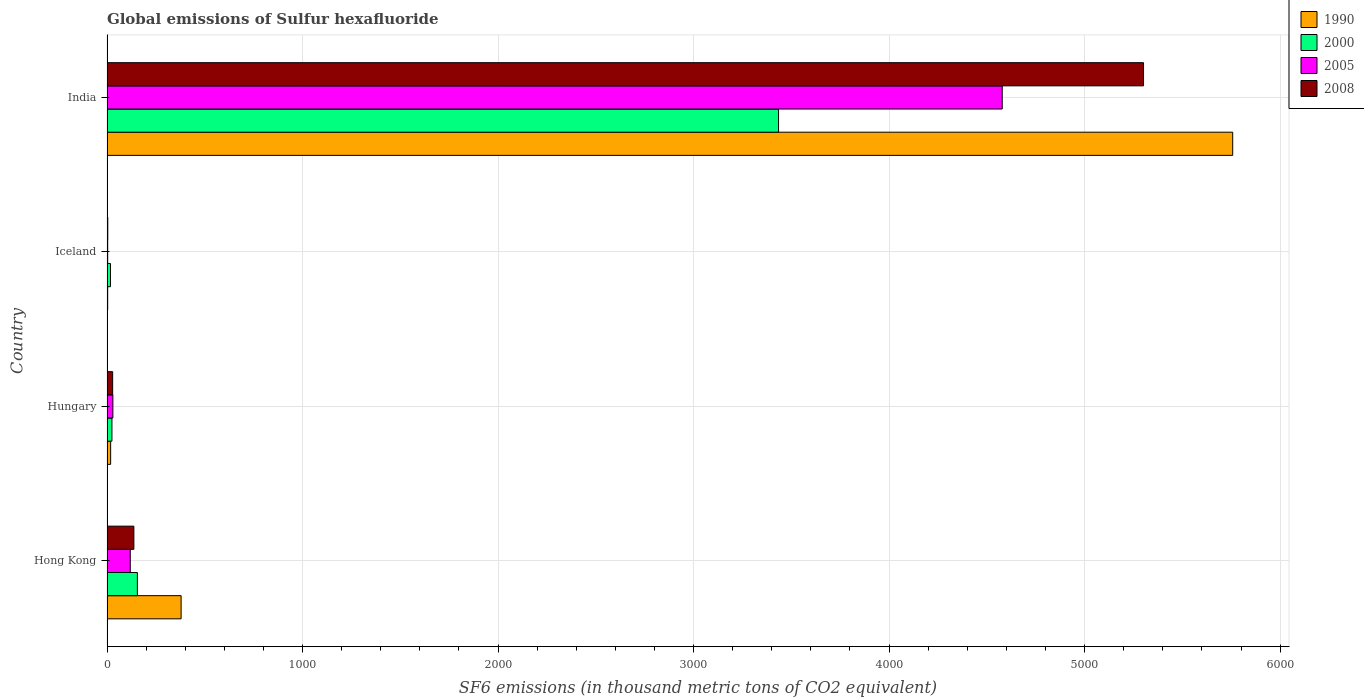How many groups of bars are there?
Provide a short and direct response. 4. Are the number of bars on each tick of the Y-axis equal?
Give a very brief answer. Yes. How many bars are there on the 4th tick from the bottom?
Offer a very short reply. 4. What is the global emissions of Sulfur hexafluoride in 1990 in India?
Keep it short and to the point. 5757.5. Across all countries, what is the maximum global emissions of Sulfur hexafluoride in 2008?
Your answer should be compact. 5301.4. In which country was the global emissions of Sulfur hexafluoride in 2000 maximum?
Keep it short and to the point. India. In which country was the global emissions of Sulfur hexafluoride in 2005 minimum?
Provide a short and direct response. Iceland. What is the total global emissions of Sulfur hexafluoride in 2000 in the graph?
Provide a short and direct response. 3633.1. What is the difference between the global emissions of Sulfur hexafluoride in 1990 in Hungary and that in Iceland?
Make the answer very short. 15.1. What is the difference between the global emissions of Sulfur hexafluoride in 2008 in India and the global emissions of Sulfur hexafluoride in 1990 in Iceland?
Give a very brief answer. 5297.9. What is the average global emissions of Sulfur hexafluoride in 1990 per country?
Ensure brevity in your answer.  1539.65. What is the difference between the global emissions of Sulfur hexafluoride in 2000 and global emissions of Sulfur hexafluoride in 2005 in Iceland?
Offer a very short reply. 14.4. Is the global emissions of Sulfur hexafluoride in 2005 in Hungary less than that in India?
Provide a short and direct response. Yes. Is the difference between the global emissions of Sulfur hexafluoride in 2000 in Hong Kong and India greater than the difference between the global emissions of Sulfur hexafluoride in 2005 in Hong Kong and India?
Offer a very short reply. Yes. What is the difference between the highest and the second highest global emissions of Sulfur hexafluoride in 2008?
Keep it short and to the point. 5164. What is the difference between the highest and the lowest global emissions of Sulfur hexafluoride in 2005?
Make the answer very short. 4575.2. How many countries are there in the graph?
Keep it short and to the point. 4. Does the graph contain grids?
Offer a very short reply. Yes. Where does the legend appear in the graph?
Offer a very short reply. Top right. How many legend labels are there?
Offer a terse response. 4. How are the legend labels stacked?
Keep it short and to the point. Vertical. What is the title of the graph?
Your answer should be compact. Global emissions of Sulfur hexafluoride. What is the label or title of the X-axis?
Keep it short and to the point. SF6 emissions (in thousand metric tons of CO2 equivalent). What is the SF6 emissions (in thousand metric tons of CO2 equivalent) of 1990 in Hong Kong?
Keep it short and to the point. 379. What is the SF6 emissions (in thousand metric tons of CO2 equivalent) in 2000 in Hong Kong?
Your answer should be very brief. 155.3. What is the SF6 emissions (in thousand metric tons of CO2 equivalent) in 2005 in Hong Kong?
Offer a very short reply. 119. What is the SF6 emissions (in thousand metric tons of CO2 equivalent) in 2008 in Hong Kong?
Offer a terse response. 137.4. What is the SF6 emissions (in thousand metric tons of CO2 equivalent) in 1990 in Hungary?
Your response must be concise. 18.6. What is the SF6 emissions (in thousand metric tons of CO2 equivalent) in 2000 in Hungary?
Give a very brief answer. 25.2. What is the SF6 emissions (in thousand metric tons of CO2 equivalent) of 2008 in Hungary?
Provide a short and direct response. 28.9. What is the SF6 emissions (in thousand metric tons of CO2 equivalent) in 1990 in Iceland?
Make the answer very short. 3.5. What is the SF6 emissions (in thousand metric tons of CO2 equivalent) of 2000 in Iceland?
Provide a short and direct response. 17.9. What is the SF6 emissions (in thousand metric tons of CO2 equivalent) in 2005 in Iceland?
Provide a short and direct response. 3.5. What is the SF6 emissions (in thousand metric tons of CO2 equivalent) in 1990 in India?
Provide a succinct answer. 5757.5. What is the SF6 emissions (in thousand metric tons of CO2 equivalent) in 2000 in India?
Provide a short and direct response. 3434.7. What is the SF6 emissions (in thousand metric tons of CO2 equivalent) in 2005 in India?
Your response must be concise. 4578.7. What is the SF6 emissions (in thousand metric tons of CO2 equivalent) in 2008 in India?
Your response must be concise. 5301.4. Across all countries, what is the maximum SF6 emissions (in thousand metric tons of CO2 equivalent) of 1990?
Provide a succinct answer. 5757.5. Across all countries, what is the maximum SF6 emissions (in thousand metric tons of CO2 equivalent) of 2000?
Make the answer very short. 3434.7. Across all countries, what is the maximum SF6 emissions (in thousand metric tons of CO2 equivalent) in 2005?
Your response must be concise. 4578.7. Across all countries, what is the maximum SF6 emissions (in thousand metric tons of CO2 equivalent) in 2008?
Provide a short and direct response. 5301.4. Across all countries, what is the minimum SF6 emissions (in thousand metric tons of CO2 equivalent) in 1990?
Keep it short and to the point. 3.5. Across all countries, what is the minimum SF6 emissions (in thousand metric tons of CO2 equivalent) of 2000?
Your answer should be very brief. 17.9. Across all countries, what is the minimum SF6 emissions (in thousand metric tons of CO2 equivalent) in 2005?
Provide a succinct answer. 3.5. What is the total SF6 emissions (in thousand metric tons of CO2 equivalent) of 1990 in the graph?
Give a very brief answer. 6158.6. What is the total SF6 emissions (in thousand metric tons of CO2 equivalent) in 2000 in the graph?
Offer a very short reply. 3633.1. What is the total SF6 emissions (in thousand metric tons of CO2 equivalent) of 2005 in the graph?
Your response must be concise. 4731.2. What is the total SF6 emissions (in thousand metric tons of CO2 equivalent) of 2008 in the graph?
Keep it short and to the point. 5471.7. What is the difference between the SF6 emissions (in thousand metric tons of CO2 equivalent) in 1990 in Hong Kong and that in Hungary?
Keep it short and to the point. 360.4. What is the difference between the SF6 emissions (in thousand metric tons of CO2 equivalent) of 2000 in Hong Kong and that in Hungary?
Provide a short and direct response. 130.1. What is the difference between the SF6 emissions (in thousand metric tons of CO2 equivalent) of 2005 in Hong Kong and that in Hungary?
Provide a short and direct response. 89. What is the difference between the SF6 emissions (in thousand metric tons of CO2 equivalent) in 2008 in Hong Kong and that in Hungary?
Ensure brevity in your answer.  108.5. What is the difference between the SF6 emissions (in thousand metric tons of CO2 equivalent) of 1990 in Hong Kong and that in Iceland?
Make the answer very short. 375.5. What is the difference between the SF6 emissions (in thousand metric tons of CO2 equivalent) in 2000 in Hong Kong and that in Iceland?
Your response must be concise. 137.4. What is the difference between the SF6 emissions (in thousand metric tons of CO2 equivalent) of 2005 in Hong Kong and that in Iceland?
Offer a very short reply. 115.5. What is the difference between the SF6 emissions (in thousand metric tons of CO2 equivalent) of 2008 in Hong Kong and that in Iceland?
Your answer should be very brief. 133.4. What is the difference between the SF6 emissions (in thousand metric tons of CO2 equivalent) in 1990 in Hong Kong and that in India?
Offer a very short reply. -5378.5. What is the difference between the SF6 emissions (in thousand metric tons of CO2 equivalent) in 2000 in Hong Kong and that in India?
Your answer should be compact. -3279.4. What is the difference between the SF6 emissions (in thousand metric tons of CO2 equivalent) of 2005 in Hong Kong and that in India?
Give a very brief answer. -4459.7. What is the difference between the SF6 emissions (in thousand metric tons of CO2 equivalent) in 2008 in Hong Kong and that in India?
Your answer should be very brief. -5164. What is the difference between the SF6 emissions (in thousand metric tons of CO2 equivalent) of 1990 in Hungary and that in Iceland?
Offer a terse response. 15.1. What is the difference between the SF6 emissions (in thousand metric tons of CO2 equivalent) in 2000 in Hungary and that in Iceland?
Give a very brief answer. 7.3. What is the difference between the SF6 emissions (in thousand metric tons of CO2 equivalent) of 2005 in Hungary and that in Iceland?
Offer a terse response. 26.5. What is the difference between the SF6 emissions (in thousand metric tons of CO2 equivalent) in 2008 in Hungary and that in Iceland?
Make the answer very short. 24.9. What is the difference between the SF6 emissions (in thousand metric tons of CO2 equivalent) of 1990 in Hungary and that in India?
Offer a terse response. -5738.9. What is the difference between the SF6 emissions (in thousand metric tons of CO2 equivalent) in 2000 in Hungary and that in India?
Offer a terse response. -3409.5. What is the difference between the SF6 emissions (in thousand metric tons of CO2 equivalent) of 2005 in Hungary and that in India?
Your answer should be very brief. -4548.7. What is the difference between the SF6 emissions (in thousand metric tons of CO2 equivalent) of 2008 in Hungary and that in India?
Ensure brevity in your answer.  -5272.5. What is the difference between the SF6 emissions (in thousand metric tons of CO2 equivalent) of 1990 in Iceland and that in India?
Your answer should be compact. -5754. What is the difference between the SF6 emissions (in thousand metric tons of CO2 equivalent) in 2000 in Iceland and that in India?
Provide a short and direct response. -3416.8. What is the difference between the SF6 emissions (in thousand metric tons of CO2 equivalent) of 2005 in Iceland and that in India?
Keep it short and to the point. -4575.2. What is the difference between the SF6 emissions (in thousand metric tons of CO2 equivalent) in 2008 in Iceland and that in India?
Keep it short and to the point. -5297.4. What is the difference between the SF6 emissions (in thousand metric tons of CO2 equivalent) of 1990 in Hong Kong and the SF6 emissions (in thousand metric tons of CO2 equivalent) of 2000 in Hungary?
Provide a succinct answer. 353.8. What is the difference between the SF6 emissions (in thousand metric tons of CO2 equivalent) in 1990 in Hong Kong and the SF6 emissions (in thousand metric tons of CO2 equivalent) in 2005 in Hungary?
Provide a short and direct response. 349. What is the difference between the SF6 emissions (in thousand metric tons of CO2 equivalent) in 1990 in Hong Kong and the SF6 emissions (in thousand metric tons of CO2 equivalent) in 2008 in Hungary?
Provide a succinct answer. 350.1. What is the difference between the SF6 emissions (in thousand metric tons of CO2 equivalent) of 2000 in Hong Kong and the SF6 emissions (in thousand metric tons of CO2 equivalent) of 2005 in Hungary?
Provide a succinct answer. 125.3. What is the difference between the SF6 emissions (in thousand metric tons of CO2 equivalent) in 2000 in Hong Kong and the SF6 emissions (in thousand metric tons of CO2 equivalent) in 2008 in Hungary?
Provide a succinct answer. 126.4. What is the difference between the SF6 emissions (in thousand metric tons of CO2 equivalent) in 2005 in Hong Kong and the SF6 emissions (in thousand metric tons of CO2 equivalent) in 2008 in Hungary?
Your answer should be very brief. 90.1. What is the difference between the SF6 emissions (in thousand metric tons of CO2 equivalent) in 1990 in Hong Kong and the SF6 emissions (in thousand metric tons of CO2 equivalent) in 2000 in Iceland?
Provide a short and direct response. 361.1. What is the difference between the SF6 emissions (in thousand metric tons of CO2 equivalent) in 1990 in Hong Kong and the SF6 emissions (in thousand metric tons of CO2 equivalent) in 2005 in Iceland?
Offer a terse response. 375.5. What is the difference between the SF6 emissions (in thousand metric tons of CO2 equivalent) of 1990 in Hong Kong and the SF6 emissions (in thousand metric tons of CO2 equivalent) of 2008 in Iceland?
Keep it short and to the point. 375. What is the difference between the SF6 emissions (in thousand metric tons of CO2 equivalent) in 2000 in Hong Kong and the SF6 emissions (in thousand metric tons of CO2 equivalent) in 2005 in Iceland?
Offer a very short reply. 151.8. What is the difference between the SF6 emissions (in thousand metric tons of CO2 equivalent) in 2000 in Hong Kong and the SF6 emissions (in thousand metric tons of CO2 equivalent) in 2008 in Iceland?
Your answer should be compact. 151.3. What is the difference between the SF6 emissions (in thousand metric tons of CO2 equivalent) in 2005 in Hong Kong and the SF6 emissions (in thousand metric tons of CO2 equivalent) in 2008 in Iceland?
Keep it short and to the point. 115. What is the difference between the SF6 emissions (in thousand metric tons of CO2 equivalent) in 1990 in Hong Kong and the SF6 emissions (in thousand metric tons of CO2 equivalent) in 2000 in India?
Ensure brevity in your answer.  -3055.7. What is the difference between the SF6 emissions (in thousand metric tons of CO2 equivalent) in 1990 in Hong Kong and the SF6 emissions (in thousand metric tons of CO2 equivalent) in 2005 in India?
Provide a succinct answer. -4199.7. What is the difference between the SF6 emissions (in thousand metric tons of CO2 equivalent) in 1990 in Hong Kong and the SF6 emissions (in thousand metric tons of CO2 equivalent) in 2008 in India?
Your response must be concise. -4922.4. What is the difference between the SF6 emissions (in thousand metric tons of CO2 equivalent) in 2000 in Hong Kong and the SF6 emissions (in thousand metric tons of CO2 equivalent) in 2005 in India?
Keep it short and to the point. -4423.4. What is the difference between the SF6 emissions (in thousand metric tons of CO2 equivalent) of 2000 in Hong Kong and the SF6 emissions (in thousand metric tons of CO2 equivalent) of 2008 in India?
Provide a succinct answer. -5146.1. What is the difference between the SF6 emissions (in thousand metric tons of CO2 equivalent) of 2005 in Hong Kong and the SF6 emissions (in thousand metric tons of CO2 equivalent) of 2008 in India?
Make the answer very short. -5182.4. What is the difference between the SF6 emissions (in thousand metric tons of CO2 equivalent) in 1990 in Hungary and the SF6 emissions (in thousand metric tons of CO2 equivalent) in 2005 in Iceland?
Give a very brief answer. 15.1. What is the difference between the SF6 emissions (in thousand metric tons of CO2 equivalent) of 1990 in Hungary and the SF6 emissions (in thousand metric tons of CO2 equivalent) of 2008 in Iceland?
Offer a terse response. 14.6. What is the difference between the SF6 emissions (in thousand metric tons of CO2 equivalent) of 2000 in Hungary and the SF6 emissions (in thousand metric tons of CO2 equivalent) of 2005 in Iceland?
Provide a succinct answer. 21.7. What is the difference between the SF6 emissions (in thousand metric tons of CO2 equivalent) of 2000 in Hungary and the SF6 emissions (in thousand metric tons of CO2 equivalent) of 2008 in Iceland?
Your response must be concise. 21.2. What is the difference between the SF6 emissions (in thousand metric tons of CO2 equivalent) in 1990 in Hungary and the SF6 emissions (in thousand metric tons of CO2 equivalent) in 2000 in India?
Your response must be concise. -3416.1. What is the difference between the SF6 emissions (in thousand metric tons of CO2 equivalent) in 1990 in Hungary and the SF6 emissions (in thousand metric tons of CO2 equivalent) in 2005 in India?
Keep it short and to the point. -4560.1. What is the difference between the SF6 emissions (in thousand metric tons of CO2 equivalent) of 1990 in Hungary and the SF6 emissions (in thousand metric tons of CO2 equivalent) of 2008 in India?
Your answer should be very brief. -5282.8. What is the difference between the SF6 emissions (in thousand metric tons of CO2 equivalent) in 2000 in Hungary and the SF6 emissions (in thousand metric tons of CO2 equivalent) in 2005 in India?
Your response must be concise. -4553.5. What is the difference between the SF6 emissions (in thousand metric tons of CO2 equivalent) in 2000 in Hungary and the SF6 emissions (in thousand metric tons of CO2 equivalent) in 2008 in India?
Ensure brevity in your answer.  -5276.2. What is the difference between the SF6 emissions (in thousand metric tons of CO2 equivalent) in 2005 in Hungary and the SF6 emissions (in thousand metric tons of CO2 equivalent) in 2008 in India?
Make the answer very short. -5271.4. What is the difference between the SF6 emissions (in thousand metric tons of CO2 equivalent) of 1990 in Iceland and the SF6 emissions (in thousand metric tons of CO2 equivalent) of 2000 in India?
Make the answer very short. -3431.2. What is the difference between the SF6 emissions (in thousand metric tons of CO2 equivalent) in 1990 in Iceland and the SF6 emissions (in thousand metric tons of CO2 equivalent) in 2005 in India?
Offer a terse response. -4575.2. What is the difference between the SF6 emissions (in thousand metric tons of CO2 equivalent) of 1990 in Iceland and the SF6 emissions (in thousand metric tons of CO2 equivalent) of 2008 in India?
Ensure brevity in your answer.  -5297.9. What is the difference between the SF6 emissions (in thousand metric tons of CO2 equivalent) in 2000 in Iceland and the SF6 emissions (in thousand metric tons of CO2 equivalent) in 2005 in India?
Provide a succinct answer. -4560.8. What is the difference between the SF6 emissions (in thousand metric tons of CO2 equivalent) in 2000 in Iceland and the SF6 emissions (in thousand metric tons of CO2 equivalent) in 2008 in India?
Provide a succinct answer. -5283.5. What is the difference between the SF6 emissions (in thousand metric tons of CO2 equivalent) of 2005 in Iceland and the SF6 emissions (in thousand metric tons of CO2 equivalent) of 2008 in India?
Offer a terse response. -5297.9. What is the average SF6 emissions (in thousand metric tons of CO2 equivalent) in 1990 per country?
Provide a succinct answer. 1539.65. What is the average SF6 emissions (in thousand metric tons of CO2 equivalent) of 2000 per country?
Provide a succinct answer. 908.27. What is the average SF6 emissions (in thousand metric tons of CO2 equivalent) in 2005 per country?
Keep it short and to the point. 1182.8. What is the average SF6 emissions (in thousand metric tons of CO2 equivalent) of 2008 per country?
Provide a short and direct response. 1367.92. What is the difference between the SF6 emissions (in thousand metric tons of CO2 equivalent) in 1990 and SF6 emissions (in thousand metric tons of CO2 equivalent) in 2000 in Hong Kong?
Your response must be concise. 223.7. What is the difference between the SF6 emissions (in thousand metric tons of CO2 equivalent) in 1990 and SF6 emissions (in thousand metric tons of CO2 equivalent) in 2005 in Hong Kong?
Offer a terse response. 260. What is the difference between the SF6 emissions (in thousand metric tons of CO2 equivalent) of 1990 and SF6 emissions (in thousand metric tons of CO2 equivalent) of 2008 in Hong Kong?
Your answer should be very brief. 241.6. What is the difference between the SF6 emissions (in thousand metric tons of CO2 equivalent) of 2000 and SF6 emissions (in thousand metric tons of CO2 equivalent) of 2005 in Hong Kong?
Your answer should be very brief. 36.3. What is the difference between the SF6 emissions (in thousand metric tons of CO2 equivalent) of 2005 and SF6 emissions (in thousand metric tons of CO2 equivalent) of 2008 in Hong Kong?
Provide a short and direct response. -18.4. What is the difference between the SF6 emissions (in thousand metric tons of CO2 equivalent) in 1990 and SF6 emissions (in thousand metric tons of CO2 equivalent) in 2005 in Hungary?
Your answer should be compact. -11.4. What is the difference between the SF6 emissions (in thousand metric tons of CO2 equivalent) in 2000 and SF6 emissions (in thousand metric tons of CO2 equivalent) in 2005 in Hungary?
Provide a succinct answer. -4.8. What is the difference between the SF6 emissions (in thousand metric tons of CO2 equivalent) in 2005 and SF6 emissions (in thousand metric tons of CO2 equivalent) in 2008 in Hungary?
Provide a short and direct response. 1.1. What is the difference between the SF6 emissions (in thousand metric tons of CO2 equivalent) of 1990 and SF6 emissions (in thousand metric tons of CO2 equivalent) of 2000 in Iceland?
Ensure brevity in your answer.  -14.4. What is the difference between the SF6 emissions (in thousand metric tons of CO2 equivalent) of 2005 and SF6 emissions (in thousand metric tons of CO2 equivalent) of 2008 in Iceland?
Make the answer very short. -0.5. What is the difference between the SF6 emissions (in thousand metric tons of CO2 equivalent) of 1990 and SF6 emissions (in thousand metric tons of CO2 equivalent) of 2000 in India?
Offer a very short reply. 2322.8. What is the difference between the SF6 emissions (in thousand metric tons of CO2 equivalent) in 1990 and SF6 emissions (in thousand metric tons of CO2 equivalent) in 2005 in India?
Provide a short and direct response. 1178.8. What is the difference between the SF6 emissions (in thousand metric tons of CO2 equivalent) in 1990 and SF6 emissions (in thousand metric tons of CO2 equivalent) in 2008 in India?
Provide a short and direct response. 456.1. What is the difference between the SF6 emissions (in thousand metric tons of CO2 equivalent) of 2000 and SF6 emissions (in thousand metric tons of CO2 equivalent) of 2005 in India?
Make the answer very short. -1144. What is the difference between the SF6 emissions (in thousand metric tons of CO2 equivalent) of 2000 and SF6 emissions (in thousand metric tons of CO2 equivalent) of 2008 in India?
Your response must be concise. -1866.7. What is the difference between the SF6 emissions (in thousand metric tons of CO2 equivalent) of 2005 and SF6 emissions (in thousand metric tons of CO2 equivalent) of 2008 in India?
Offer a terse response. -722.7. What is the ratio of the SF6 emissions (in thousand metric tons of CO2 equivalent) of 1990 in Hong Kong to that in Hungary?
Offer a very short reply. 20.38. What is the ratio of the SF6 emissions (in thousand metric tons of CO2 equivalent) in 2000 in Hong Kong to that in Hungary?
Ensure brevity in your answer.  6.16. What is the ratio of the SF6 emissions (in thousand metric tons of CO2 equivalent) in 2005 in Hong Kong to that in Hungary?
Offer a terse response. 3.97. What is the ratio of the SF6 emissions (in thousand metric tons of CO2 equivalent) of 2008 in Hong Kong to that in Hungary?
Provide a short and direct response. 4.75. What is the ratio of the SF6 emissions (in thousand metric tons of CO2 equivalent) in 1990 in Hong Kong to that in Iceland?
Provide a short and direct response. 108.29. What is the ratio of the SF6 emissions (in thousand metric tons of CO2 equivalent) of 2000 in Hong Kong to that in Iceland?
Your answer should be compact. 8.68. What is the ratio of the SF6 emissions (in thousand metric tons of CO2 equivalent) of 2008 in Hong Kong to that in Iceland?
Offer a terse response. 34.35. What is the ratio of the SF6 emissions (in thousand metric tons of CO2 equivalent) of 1990 in Hong Kong to that in India?
Offer a very short reply. 0.07. What is the ratio of the SF6 emissions (in thousand metric tons of CO2 equivalent) of 2000 in Hong Kong to that in India?
Provide a succinct answer. 0.05. What is the ratio of the SF6 emissions (in thousand metric tons of CO2 equivalent) in 2005 in Hong Kong to that in India?
Give a very brief answer. 0.03. What is the ratio of the SF6 emissions (in thousand metric tons of CO2 equivalent) of 2008 in Hong Kong to that in India?
Offer a very short reply. 0.03. What is the ratio of the SF6 emissions (in thousand metric tons of CO2 equivalent) in 1990 in Hungary to that in Iceland?
Your answer should be very brief. 5.31. What is the ratio of the SF6 emissions (in thousand metric tons of CO2 equivalent) in 2000 in Hungary to that in Iceland?
Your answer should be very brief. 1.41. What is the ratio of the SF6 emissions (in thousand metric tons of CO2 equivalent) in 2005 in Hungary to that in Iceland?
Provide a short and direct response. 8.57. What is the ratio of the SF6 emissions (in thousand metric tons of CO2 equivalent) in 2008 in Hungary to that in Iceland?
Give a very brief answer. 7.22. What is the ratio of the SF6 emissions (in thousand metric tons of CO2 equivalent) of 1990 in Hungary to that in India?
Make the answer very short. 0. What is the ratio of the SF6 emissions (in thousand metric tons of CO2 equivalent) of 2000 in Hungary to that in India?
Ensure brevity in your answer.  0.01. What is the ratio of the SF6 emissions (in thousand metric tons of CO2 equivalent) in 2005 in Hungary to that in India?
Your response must be concise. 0.01. What is the ratio of the SF6 emissions (in thousand metric tons of CO2 equivalent) of 2008 in Hungary to that in India?
Offer a very short reply. 0.01. What is the ratio of the SF6 emissions (in thousand metric tons of CO2 equivalent) of 1990 in Iceland to that in India?
Offer a terse response. 0. What is the ratio of the SF6 emissions (in thousand metric tons of CO2 equivalent) in 2000 in Iceland to that in India?
Make the answer very short. 0.01. What is the ratio of the SF6 emissions (in thousand metric tons of CO2 equivalent) in 2005 in Iceland to that in India?
Offer a terse response. 0. What is the ratio of the SF6 emissions (in thousand metric tons of CO2 equivalent) in 2008 in Iceland to that in India?
Make the answer very short. 0. What is the difference between the highest and the second highest SF6 emissions (in thousand metric tons of CO2 equivalent) in 1990?
Provide a succinct answer. 5378.5. What is the difference between the highest and the second highest SF6 emissions (in thousand metric tons of CO2 equivalent) in 2000?
Give a very brief answer. 3279.4. What is the difference between the highest and the second highest SF6 emissions (in thousand metric tons of CO2 equivalent) in 2005?
Make the answer very short. 4459.7. What is the difference between the highest and the second highest SF6 emissions (in thousand metric tons of CO2 equivalent) in 2008?
Your answer should be compact. 5164. What is the difference between the highest and the lowest SF6 emissions (in thousand metric tons of CO2 equivalent) in 1990?
Offer a very short reply. 5754. What is the difference between the highest and the lowest SF6 emissions (in thousand metric tons of CO2 equivalent) in 2000?
Your answer should be very brief. 3416.8. What is the difference between the highest and the lowest SF6 emissions (in thousand metric tons of CO2 equivalent) of 2005?
Ensure brevity in your answer.  4575.2. What is the difference between the highest and the lowest SF6 emissions (in thousand metric tons of CO2 equivalent) of 2008?
Your response must be concise. 5297.4. 